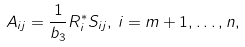<formula> <loc_0><loc_0><loc_500><loc_500>A _ { i j } = { \frac { 1 } { b _ { 3 } } } R _ { i } ^ { * } S _ { i j } , \, i = m + 1 , \dots , n ,</formula> 